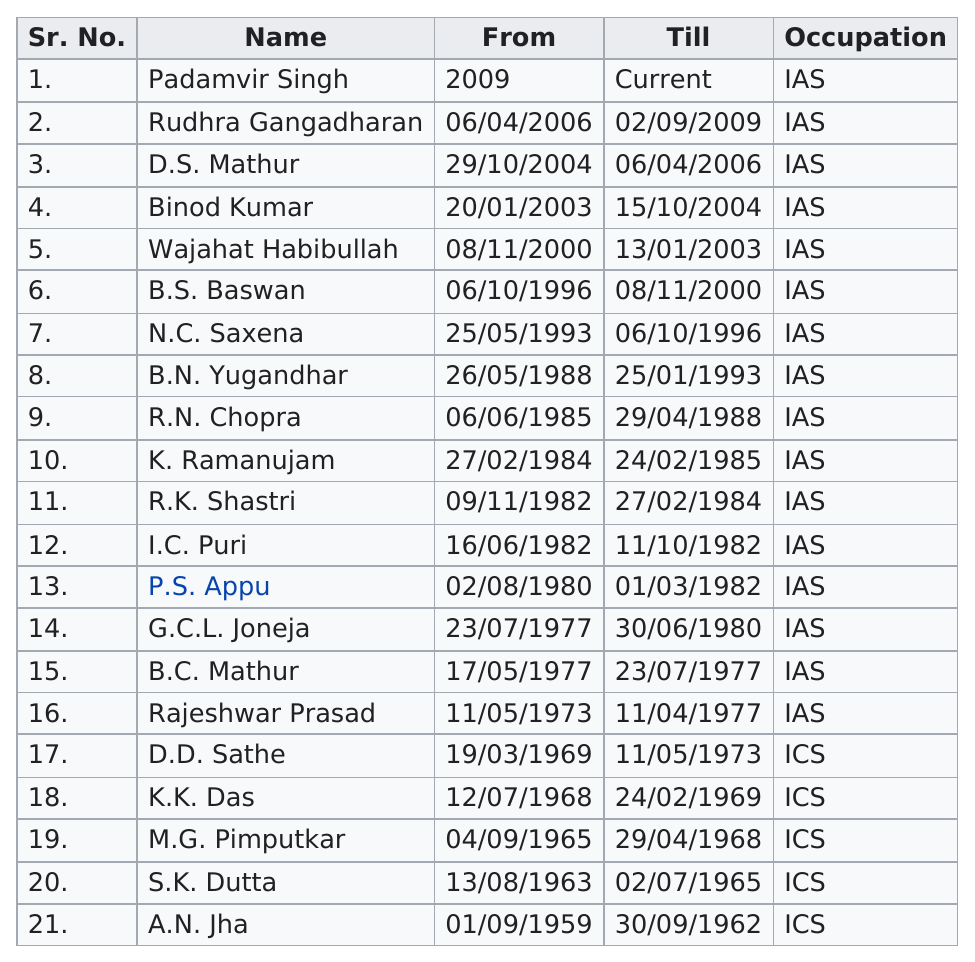Draw attention to some important aspects in this diagram. B.N. Yugandhar served the most years as the director. During the period of 2000 to 2009, there were 5 directors. There were 16 directors who held the position of Fias during the specified time period. A.N. Jha was the only director who began working in the 1950s. Rudhra Gangadharan served before the current director, who served before the current director? 